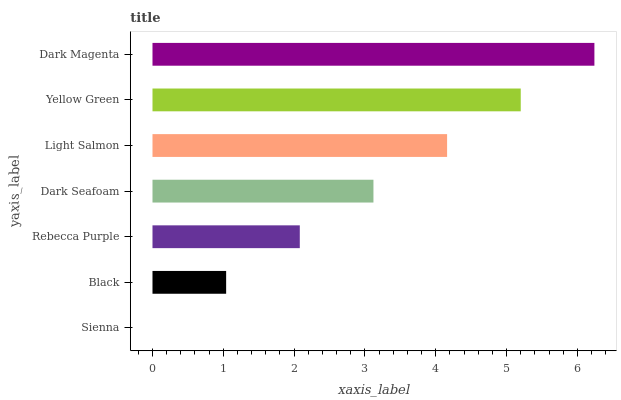Is Sienna the minimum?
Answer yes or no. Yes. Is Dark Magenta the maximum?
Answer yes or no. Yes. Is Black the minimum?
Answer yes or no. No. Is Black the maximum?
Answer yes or no. No. Is Black greater than Sienna?
Answer yes or no. Yes. Is Sienna less than Black?
Answer yes or no. Yes. Is Sienna greater than Black?
Answer yes or no. No. Is Black less than Sienna?
Answer yes or no. No. Is Dark Seafoam the high median?
Answer yes or no. Yes. Is Dark Seafoam the low median?
Answer yes or no. Yes. Is Dark Magenta the high median?
Answer yes or no. No. Is Sienna the low median?
Answer yes or no. No. 